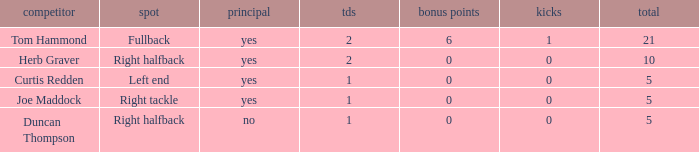Name the number of points for field goals being 1 1.0. 